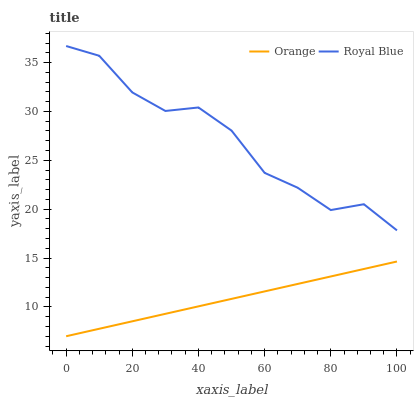Does Orange have the minimum area under the curve?
Answer yes or no. Yes. Does Royal Blue have the maximum area under the curve?
Answer yes or no. Yes. Does Royal Blue have the minimum area under the curve?
Answer yes or no. No. Is Orange the smoothest?
Answer yes or no. Yes. Is Royal Blue the roughest?
Answer yes or no. Yes. Is Royal Blue the smoothest?
Answer yes or no. No. Does Orange have the lowest value?
Answer yes or no. Yes. Does Royal Blue have the lowest value?
Answer yes or no. No. Does Royal Blue have the highest value?
Answer yes or no. Yes. Is Orange less than Royal Blue?
Answer yes or no. Yes. Is Royal Blue greater than Orange?
Answer yes or no. Yes. Does Orange intersect Royal Blue?
Answer yes or no. No. 